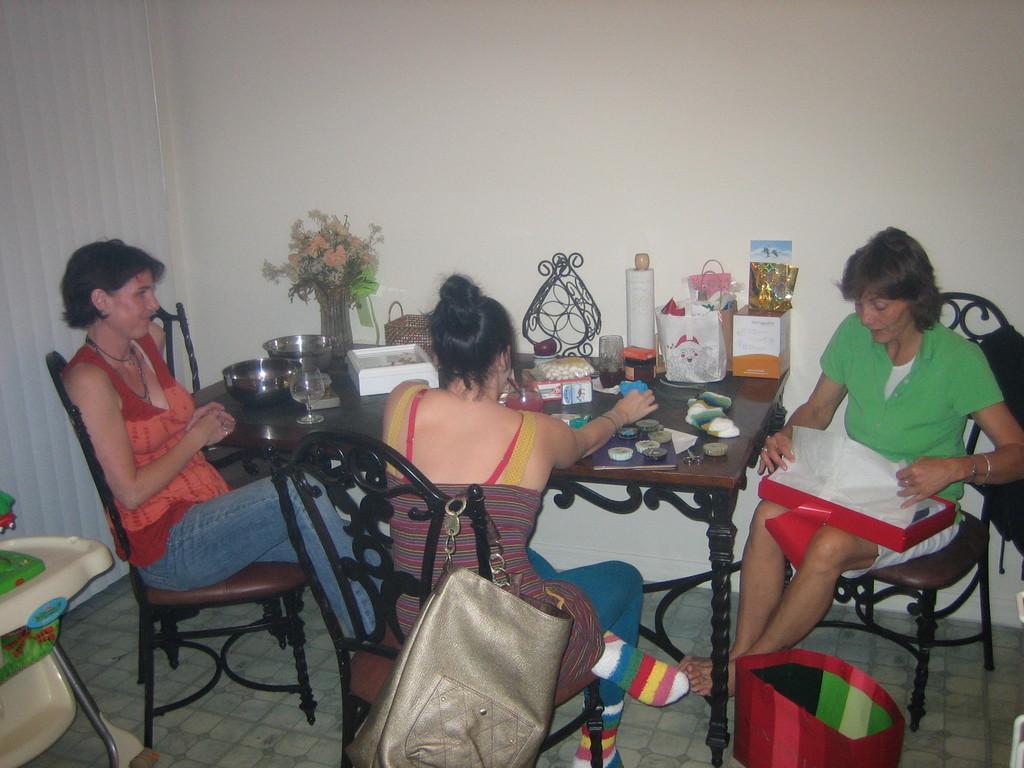In one or two sentences, can you explain what this image depicts? This 3 women are sitting on a chair. On this chair a bag is hanging. This is a baby sitting chair. In-front of this woman there is a table, on a table there is a bowl, flower vase with flowers, box and things. On this woman lap there is a box. Beside this table there is a container. 